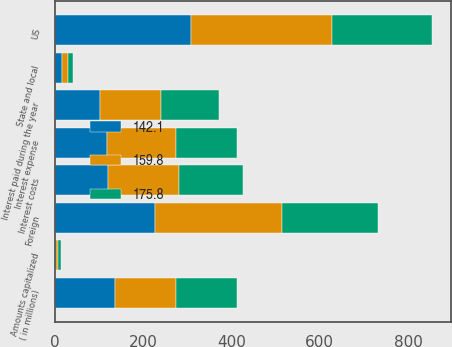<chart> <loc_0><loc_0><loc_500><loc_500><stacked_bar_chart><ecel><fcel>( in millions)<fcel>Interest costs<fcel>Amounts capitalized<fcel>Interest expense<fcel>Interest paid during the year<fcel>US<fcel>Foreign<fcel>State and local<nl><fcel>159.8<fcel>137.2<fcel>161.1<fcel>2.9<fcel>158.2<fcel>137.2<fcel>319.3<fcel>287.1<fcel>12.5<nl><fcel>142.1<fcel>137.2<fcel>120.8<fcel>3.6<fcel>117.2<fcel>103.1<fcel>309.2<fcel>227.4<fcel>16.4<nl><fcel>175.8<fcel>137.2<fcel>144.9<fcel>7.2<fcel>137.7<fcel>132.4<fcel>226.5<fcel>216.4<fcel>12.1<nl></chart> 